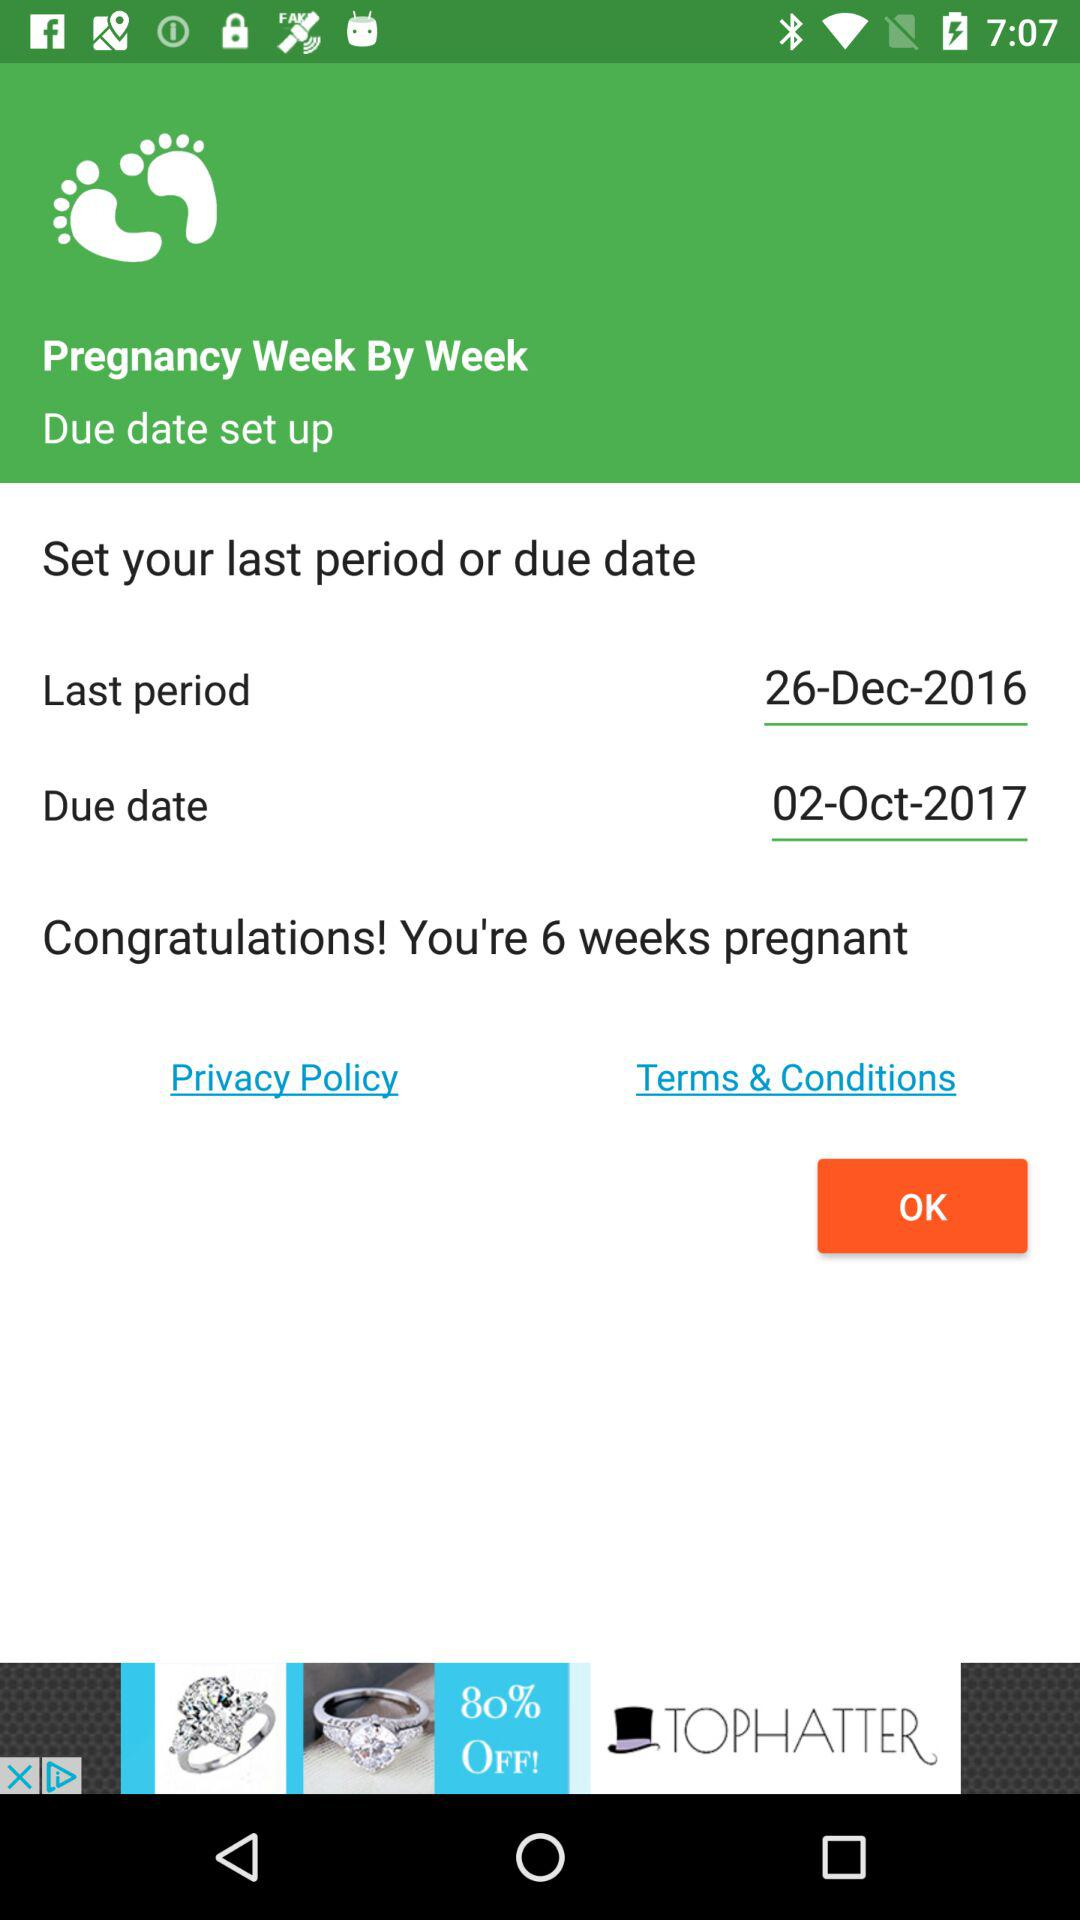What is the date of the last period? The date of the last period is December 26, 2016. 